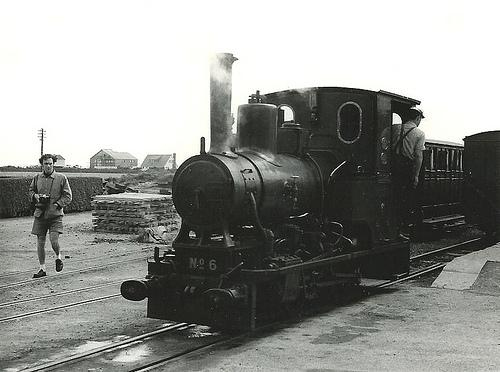Count how many objects related to the train are specified in the image section. Ten objects related to the train are specified: white letters, steam, train on tracks, black train engine, train conductor, front of the train, bottom of the train, track in front, train engine blowing smoke, and window on the front. Kindly expound on the appearance of the train conductor and his actions. The train conductor is wearing suspenders, leaning out of the train engine, and seems to be observing the surroundings while performing his duties. What is the primary vehicle present in the image? The primary vehicle present in the image is a train on tracks. In a few words, describe any structures in the background of the image. There are a white building resembling a home, a large building resembling a business, and an electrical pole in the background. What action is the person inside the train performing? The person inside the train is looking out of a window. Please, enumerate some elements that can be found near the train. Elements near the train include a stack of pallets, a stack of wood, an electrical pole, and tracks. Briefly describe the train engine and any distinctive markings on it. The train engine is black, on tracks, and has the number 6 painted on its front. It is also blowing out steam or smoke. Analyze the sentiment of the scene through a brief statement. The scene conveys a sense of nostalgic charm and industrial history, as people interact with the large, old-fashioned steam train. What is unique about a man in the image, and what is he holding? The man in the image is wearing a coat and shorts, and he is holding a camera. List down the objects that can be seen in the background of the scene. Electrical pole, building resembling a home, building resembling a business What unique feature can be found on the front of the train? word painted on front of train Write a short description of the man holding a camera, including his actions. A man is holding a camera, but his facial expression is not visible. What object can be identified behind the man holding the camera? electric pole What is the main activity taking place in the image involving the train? train engine is blowing out smoke Identify objects placed on the ground in the scene. Stack of pallets and stack of wood Can you spot any person inside the train? Yes, there is a person in the train. Describe the emotional state of the man holding the camera. facial expression is not visible What is the main object found below the train?  train tracks Identify the features or objects that can be associated with the train in the image. white letters, steam, engine, number 6, black passenger car, window, train tracks What is the color of the letters painted on the train? white Does the train conductor appear to be wearing any specific type of clothing? train conductor is wearing suspenders Write a sentence that describes the action involving the steam. Steam is coming out of the train. Describe the attire of the man standing near the train. wearing a coat and shorts What is the number painted on the front of the train engine? 6 What is the train conductor doing in the scene? leaning out of the engine In the scene, who appears to be wearing a collar? The information is not clear Which of the following objects is present near the train tracks: stack of wood, stack of pallets, or stack of bricks? stack of wood What part of the train is the window on? front of the train 